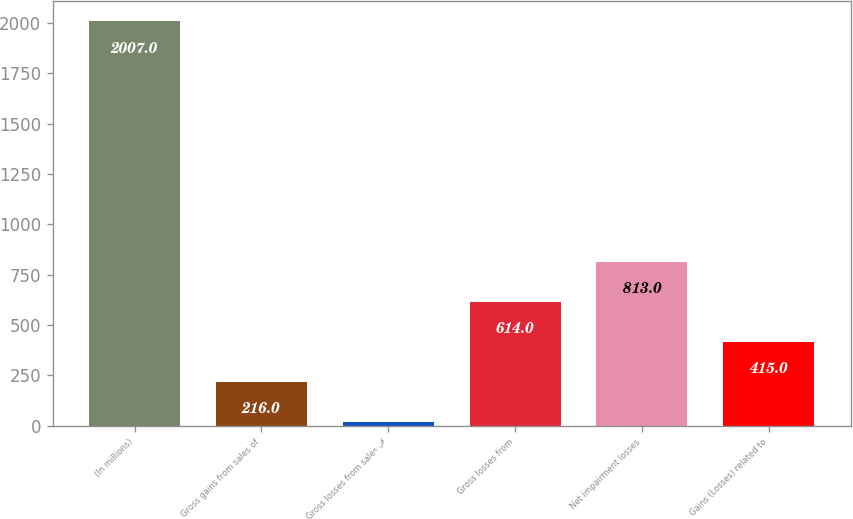Convert chart. <chart><loc_0><loc_0><loc_500><loc_500><bar_chart><fcel>(In millions)<fcel>Gross gains from sales of<fcel>Gross losses from sales of<fcel>Gross losses from<fcel>Net impairment losses<fcel>Gains (Losses) related to<nl><fcel>2007<fcel>216<fcel>17<fcel>614<fcel>813<fcel>415<nl></chart> 